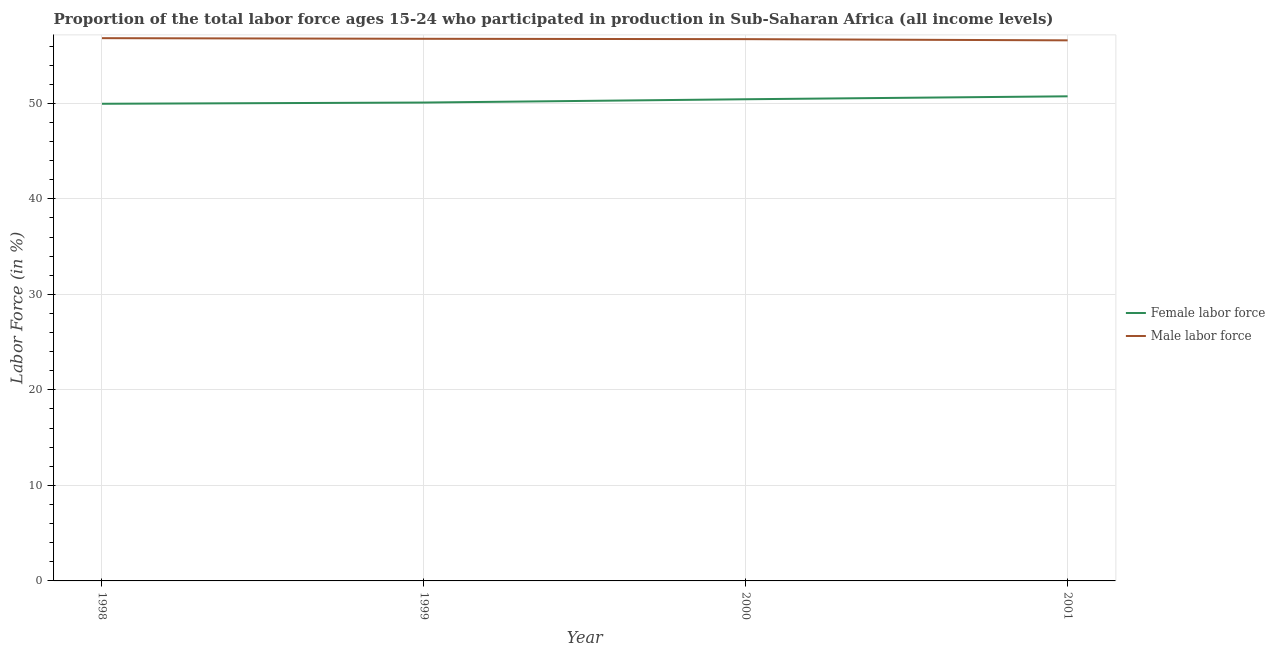Does the line corresponding to percentage of female labor force intersect with the line corresponding to percentage of male labour force?
Ensure brevity in your answer.  No. What is the percentage of female labor force in 2000?
Make the answer very short. 50.43. Across all years, what is the maximum percentage of female labor force?
Ensure brevity in your answer.  50.74. Across all years, what is the minimum percentage of female labor force?
Provide a succinct answer. 49.96. In which year was the percentage of female labor force maximum?
Make the answer very short. 2001. In which year was the percentage of male labour force minimum?
Offer a terse response. 2001. What is the total percentage of female labor force in the graph?
Ensure brevity in your answer.  201.21. What is the difference between the percentage of male labour force in 1998 and that in 2000?
Provide a short and direct response. 0.1. What is the difference between the percentage of male labour force in 2000 and the percentage of female labor force in 1998?
Offer a terse response. 6.77. What is the average percentage of female labor force per year?
Provide a succinct answer. 50.3. In the year 2001, what is the difference between the percentage of female labor force and percentage of male labour force?
Give a very brief answer. -5.86. What is the ratio of the percentage of female labor force in 1998 to that in 1999?
Your answer should be very brief. 1. What is the difference between the highest and the second highest percentage of male labour force?
Provide a succinct answer. 0.07. What is the difference between the highest and the lowest percentage of male labour force?
Your answer should be compact. 0.23. In how many years, is the percentage of male labour force greater than the average percentage of male labour force taken over all years?
Make the answer very short. 2. Does the percentage of male labour force monotonically increase over the years?
Give a very brief answer. No. How many lines are there?
Offer a very short reply. 2. What is the difference between two consecutive major ticks on the Y-axis?
Your response must be concise. 10. Are the values on the major ticks of Y-axis written in scientific E-notation?
Your response must be concise. No. Does the graph contain any zero values?
Keep it short and to the point. No. Does the graph contain grids?
Your response must be concise. Yes. Where does the legend appear in the graph?
Offer a very short reply. Center right. How many legend labels are there?
Keep it short and to the point. 2. How are the legend labels stacked?
Your answer should be very brief. Vertical. What is the title of the graph?
Ensure brevity in your answer.  Proportion of the total labor force ages 15-24 who participated in production in Sub-Saharan Africa (all income levels). Does "Time to export" appear as one of the legend labels in the graph?
Offer a terse response. No. What is the label or title of the Y-axis?
Give a very brief answer. Labor Force (in %). What is the Labor Force (in %) of Female labor force in 1998?
Keep it short and to the point. 49.96. What is the Labor Force (in %) in Male labor force in 1998?
Ensure brevity in your answer.  56.83. What is the Labor Force (in %) in Female labor force in 1999?
Offer a very short reply. 50.08. What is the Labor Force (in %) in Male labor force in 1999?
Provide a succinct answer. 56.76. What is the Labor Force (in %) in Female labor force in 2000?
Ensure brevity in your answer.  50.43. What is the Labor Force (in %) in Male labor force in 2000?
Ensure brevity in your answer.  56.72. What is the Labor Force (in %) in Female labor force in 2001?
Provide a short and direct response. 50.74. What is the Labor Force (in %) in Male labor force in 2001?
Make the answer very short. 56.6. Across all years, what is the maximum Labor Force (in %) in Female labor force?
Your answer should be very brief. 50.74. Across all years, what is the maximum Labor Force (in %) in Male labor force?
Your response must be concise. 56.83. Across all years, what is the minimum Labor Force (in %) of Female labor force?
Offer a terse response. 49.96. Across all years, what is the minimum Labor Force (in %) in Male labor force?
Offer a very short reply. 56.6. What is the total Labor Force (in %) in Female labor force in the graph?
Provide a short and direct response. 201.21. What is the total Labor Force (in %) in Male labor force in the graph?
Provide a succinct answer. 226.9. What is the difference between the Labor Force (in %) in Female labor force in 1998 and that in 1999?
Make the answer very short. -0.13. What is the difference between the Labor Force (in %) in Male labor force in 1998 and that in 1999?
Give a very brief answer. 0.07. What is the difference between the Labor Force (in %) of Female labor force in 1998 and that in 2000?
Make the answer very short. -0.47. What is the difference between the Labor Force (in %) of Male labor force in 1998 and that in 2000?
Provide a short and direct response. 0.1. What is the difference between the Labor Force (in %) in Female labor force in 1998 and that in 2001?
Offer a terse response. -0.78. What is the difference between the Labor Force (in %) in Male labor force in 1998 and that in 2001?
Ensure brevity in your answer.  0.23. What is the difference between the Labor Force (in %) of Female labor force in 1999 and that in 2000?
Offer a terse response. -0.35. What is the difference between the Labor Force (in %) in Male labor force in 1999 and that in 2000?
Make the answer very short. 0.04. What is the difference between the Labor Force (in %) of Female labor force in 1999 and that in 2001?
Your response must be concise. -0.65. What is the difference between the Labor Force (in %) of Male labor force in 1999 and that in 2001?
Provide a succinct answer. 0.16. What is the difference between the Labor Force (in %) in Female labor force in 2000 and that in 2001?
Make the answer very short. -0.31. What is the difference between the Labor Force (in %) of Male labor force in 2000 and that in 2001?
Provide a succinct answer. 0.13. What is the difference between the Labor Force (in %) in Female labor force in 1998 and the Labor Force (in %) in Male labor force in 1999?
Ensure brevity in your answer.  -6.8. What is the difference between the Labor Force (in %) of Female labor force in 1998 and the Labor Force (in %) of Male labor force in 2000?
Your answer should be compact. -6.77. What is the difference between the Labor Force (in %) of Female labor force in 1998 and the Labor Force (in %) of Male labor force in 2001?
Ensure brevity in your answer.  -6.64. What is the difference between the Labor Force (in %) in Female labor force in 1999 and the Labor Force (in %) in Male labor force in 2000?
Your answer should be compact. -6.64. What is the difference between the Labor Force (in %) in Female labor force in 1999 and the Labor Force (in %) in Male labor force in 2001?
Provide a short and direct response. -6.51. What is the difference between the Labor Force (in %) in Female labor force in 2000 and the Labor Force (in %) in Male labor force in 2001?
Ensure brevity in your answer.  -6.17. What is the average Labor Force (in %) of Female labor force per year?
Offer a terse response. 50.3. What is the average Labor Force (in %) of Male labor force per year?
Your response must be concise. 56.73. In the year 1998, what is the difference between the Labor Force (in %) of Female labor force and Labor Force (in %) of Male labor force?
Your answer should be compact. -6.87. In the year 1999, what is the difference between the Labor Force (in %) in Female labor force and Labor Force (in %) in Male labor force?
Keep it short and to the point. -6.68. In the year 2000, what is the difference between the Labor Force (in %) in Female labor force and Labor Force (in %) in Male labor force?
Your answer should be compact. -6.29. In the year 2001, what is the difference between the Labor Force (in %) of Female labor force and Labor Force (in %) of Male labor force?
Offer a terse response. -5.86. What is the ratio of the Labor Force (in %) of Female labor force in 1998 to that in 2000?
Give a very brief answer. 0.99. What is the ratio of the Labor Force (in %) of Female labor force in 1998 to that in 2001?
Provide a succinct answer. 0.98. What is the ratio of the Labor Force (in %) in Male labor force in 1999 to that in 2000?
Ensure brevity in your answer.  1. What is the ratio of the Labor Force (in %) in Female labor force in 1999 to that in 2001?
Offer a terse response. 0.99. What is the ratio of the Labor Force (in %) of Male labor force in 1999 to that in 2001?
Offer a very short reply. 1. What is the ratio of the Labor Force (in %) in Female labor force in 2000 to that in 2001?
Provide a succinct answer. 0.99. What is the difference between the highest and the second highest Labor Force (in %) of Female labor force?
Your answer should be very brief. 0.31. What is the difference between the highest and the second highest Labor Force (in %) of Male labor force?
Your answer should be compact. 0.07. What is the difference between the highest and the lowest Labor Force (in %) of Female labor force?
Make the answer very short. 0.78. What is the difference between the highest and the lowest Labor Force (in %) of Male labor force?
Offer a terse response. 0.23. 